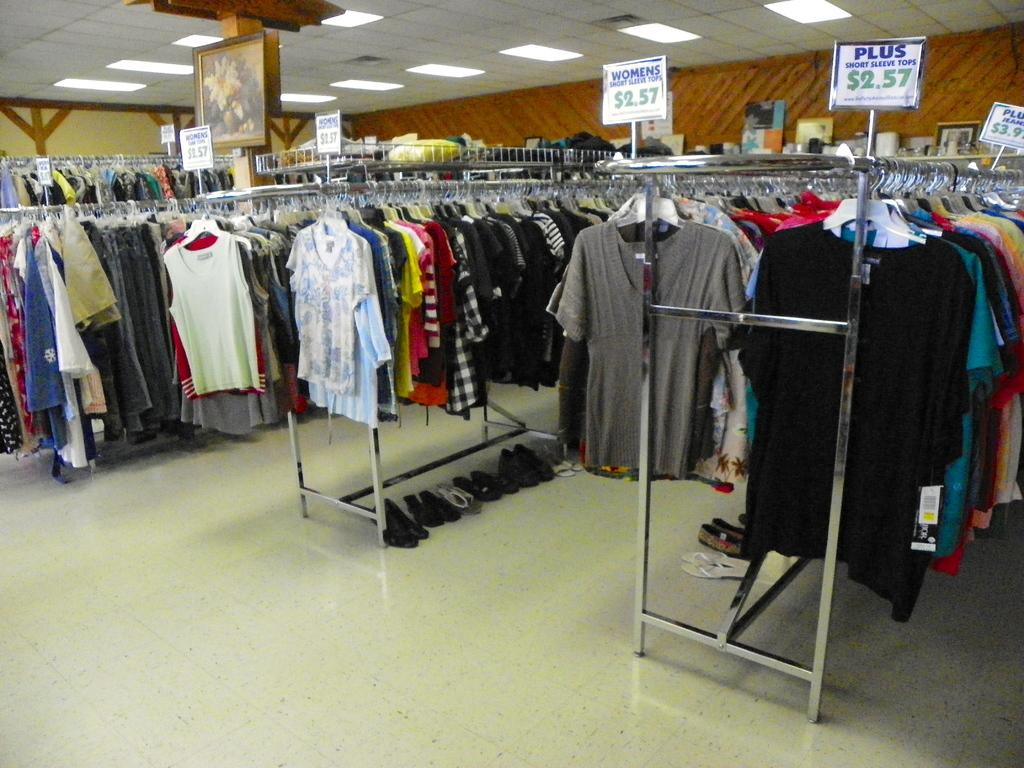<image>
Provide a brief description of the given image. A rack of clothing, one of which is advertising clothes for 2.57 